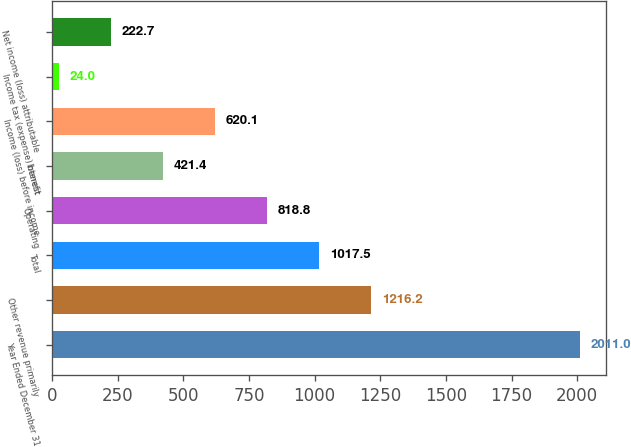<chart> <loc_0><loc_0><loc_500><loc_500><bar_chart><fcel>Year Ended December 31<fcel>Other revenue primarily<fcel>Total<fcel>Operating<fcel>Interest<fcel>Income (loss) before income<fcel>Income tax (expense) benefit<fcel>Net income (loss) attributable<nl><fcel>2011<fcel>1216.2<fcel>1017.5<fcel>818.8<fcel>421.4<fcel>620.1<fcel>24<fcel>222.7<nl></chart> 